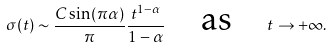Convert formula to latex. <formula><loc_0><loc_0><loc_500><loc_500>\sigma ( t ) \sim \frac { C \sin ( \pi \alpha ) } { \pi } \frac { t ^ { 1 - \alpha } } { 1 - \alpha } \quad \text {as} \quad t \to + \infty .</formula> 